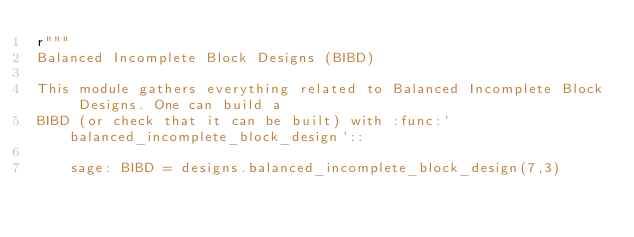Convert code to text. <code><loc_0><loc_0><loc_500><loc_500><_Python_>r"""
Balanced Incomplete Block Designs (BIBD)

This module gathers everything related to Balanced Incomplete Block Designs. One can build a
BIBD (or check that it can be built) with :func:`balanced_incomplete_block_design`::

    sage: BIBD = designs.balanced_incomplete_block_design(7,3)
</code> 